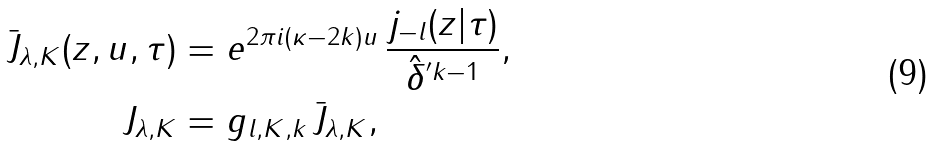<formula> <loc_0><loc_0><loc_500><loc_500>\bar { J } _ { \lambda , K } ( z , u , \tau ) & = e ^ { 2 \pi i ( \kappa - 2 k ) u } \, \frac { j _ { - l } ( z | \tau ) } { \hat { \delta } ^ { ^ { \prime } k - 1 } } , \\ J _ { \lambda , K } & = g _ { l , K , k } \, \bar { J } _ { \lambda , K } ,</formula> 